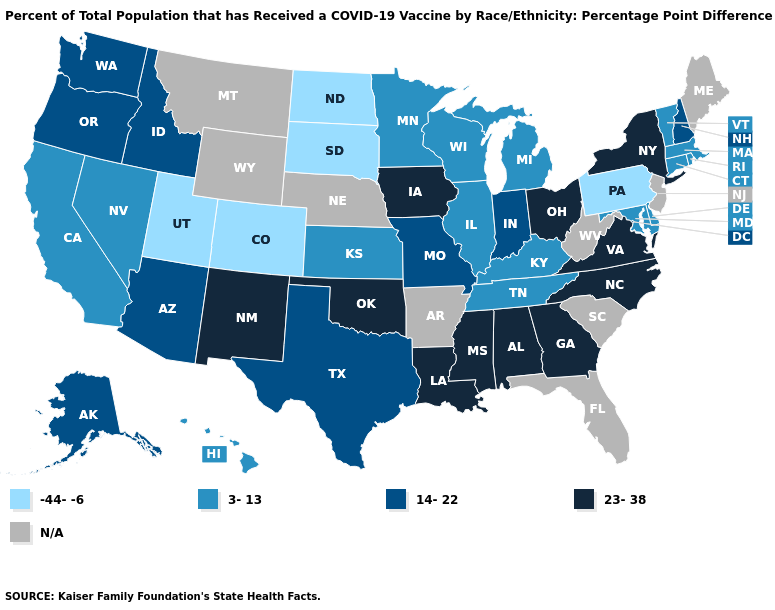Name the states that have a value in the range N/A?
Be succinct. Arkansas, Florida, Maine, Montana, Nebraska, New Jersey, South Carolina, West Virginia, Wyoming. What is the value of Missouri?
Be succinct. 14-22. Which states have the lowest value in the West?
Be succinct. Colorado, Utah. Which states hav the highest value in the West?
Give a very brief answer. New Mexico. Does South Dakota have the highest value in the USA?
Write a very short answer. No. Name the states that have a value in the range N/A?
Quick response, please. Arkansas, Florida, Maine, Montana, Nebraska, New Jersey, South Carolina, West Virginia, Wyoming. Name the states that have a value in the range 14-22?
Be succinct. Alaska, Arizona, Idaho, Indiana, Missouri, New Hampshire, Oregon, Texas, Washington. What is the value of North Carolina?
Short answer required. 23-38. Is the legend a continuous bar?
Be succinct. No. What is the highest value in the Northeast ?
Concise answer only. 23-38. What is the lowest value in states that border New Hampshire?
Give a very brief answer. 3-13. Which states have the lowest value in the USA?
Concise answer only. Colorado, North Dakota, Pennsylvania, South Dakota, Utah. Name the states that have a value in the range N/A?
Answer briefly. Arkansas, Florida, Maine, Montana, Nebraska, New Jersey, South Carolina, West Virginia, Wyoming. 